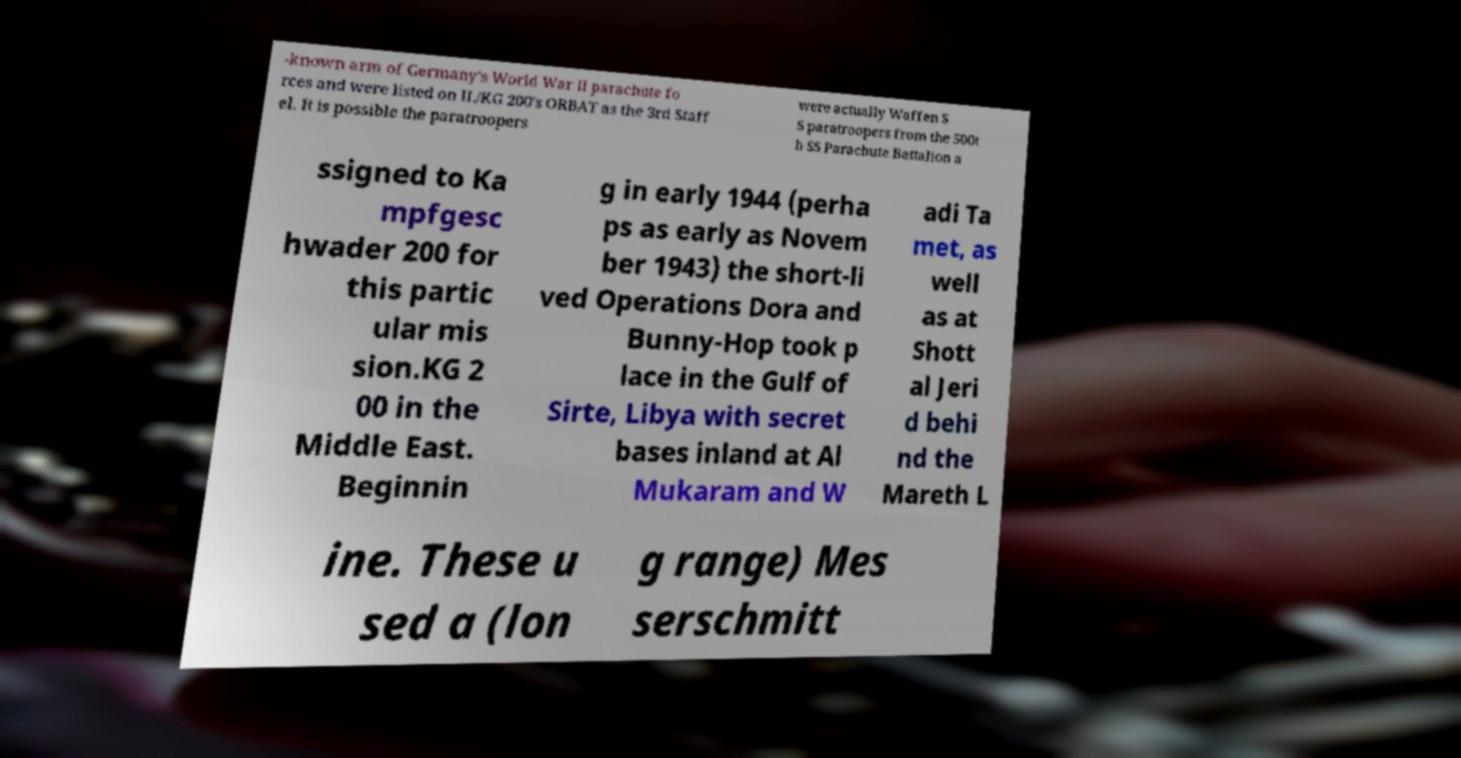Could you extract and type out the text from this image? -known arm of Germany's World War II parachute fo rces and were listed on II./KG 200's ORBAT as the 3rd Staff el. It is possible the paratroopers were actually Waffen S S paratroopers from the 500t h SS Parachute Battalion a ssigned to Ka mpfgesc hwader 200 for this partic ular mis sion.KG 2 00 in the Middle East. Beginnin g in early 1944 (perha ps as early as Novem ber 1943) the short-li ved Operations Dora and Bunny-Hop took p lace in the Gulf of Sirte, Libya with secret bases inland at Al Mukaram and W adi Ta met, as well as at Shott al Jeri d behi nd the Mareth L ine. These u sed a (lon g range) Mes serschmitt 